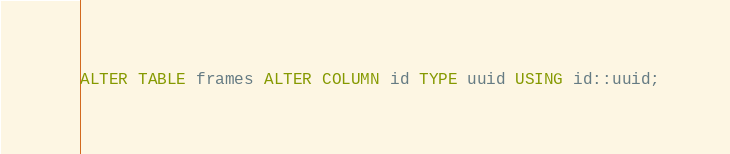<code> <loc_0><loc_0><loc_500><loc_500><_SQL_>ALTER TABLE frames ALTER COLUMN id TYPE uuid USING id::uuid;
</code> 